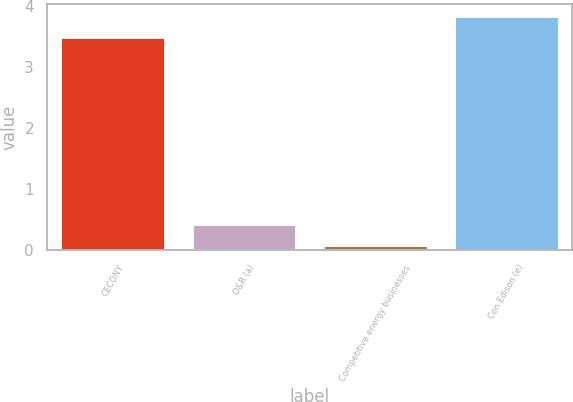<chart> <loc_0><loc_0><loc_500><loc_500><bar_chart><fcel>CECONY<fcel>O&R (a)<fcel>Competitive energy businesses<fcel>Con Edison (e)<nl><fcel>3.48<fcel>0.43<fcel>0.08<fcel>3.83<nl></chart> 